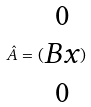Convert formula to latex. <formula><loc_0><loc_0><loc_500><loc_500>\hat { A } = ( \begin{matrix} 0 \\ B x \\ 0 \end{matrix} )</formula> 